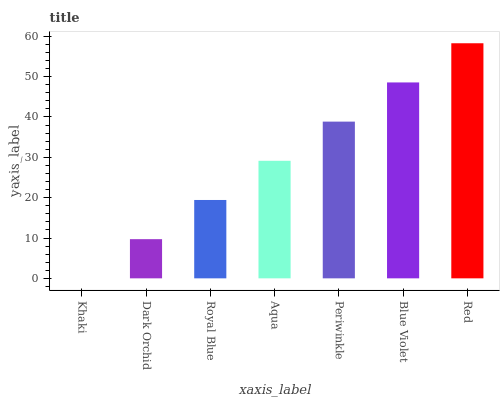Is Red the maximum?
Answer yes or no. Yes. Is Dark Orchid the minimum?
Answer yes or no. No. Is Dark Orchid the maximum?
Answer yes or no. No. Is Dark Orchid greater than Khaki?
Answer yes or no. Yes. Is Khaki less than Dark Orchid?
Answer yes or no. Yes. Is Khaki greater than Dark Orchid?
Answer yes or no. No. Is Dark Orchid less than Khaki?
Answer yes or no. No. Is Aqua the high median?
Answer yes or no. Yes. Is Aqua the low median?
Answer yes or no. Yes. Is Royal Blue the high median?
Answer yes or no. No. Is Blue Violet the low median?
Answer yes or no. No. 